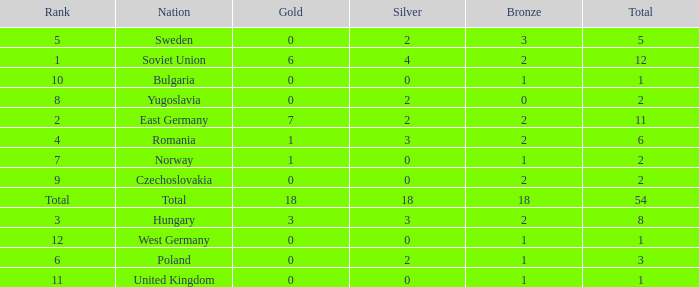What's the total of rank number 6 with more than 2 silver? None. 